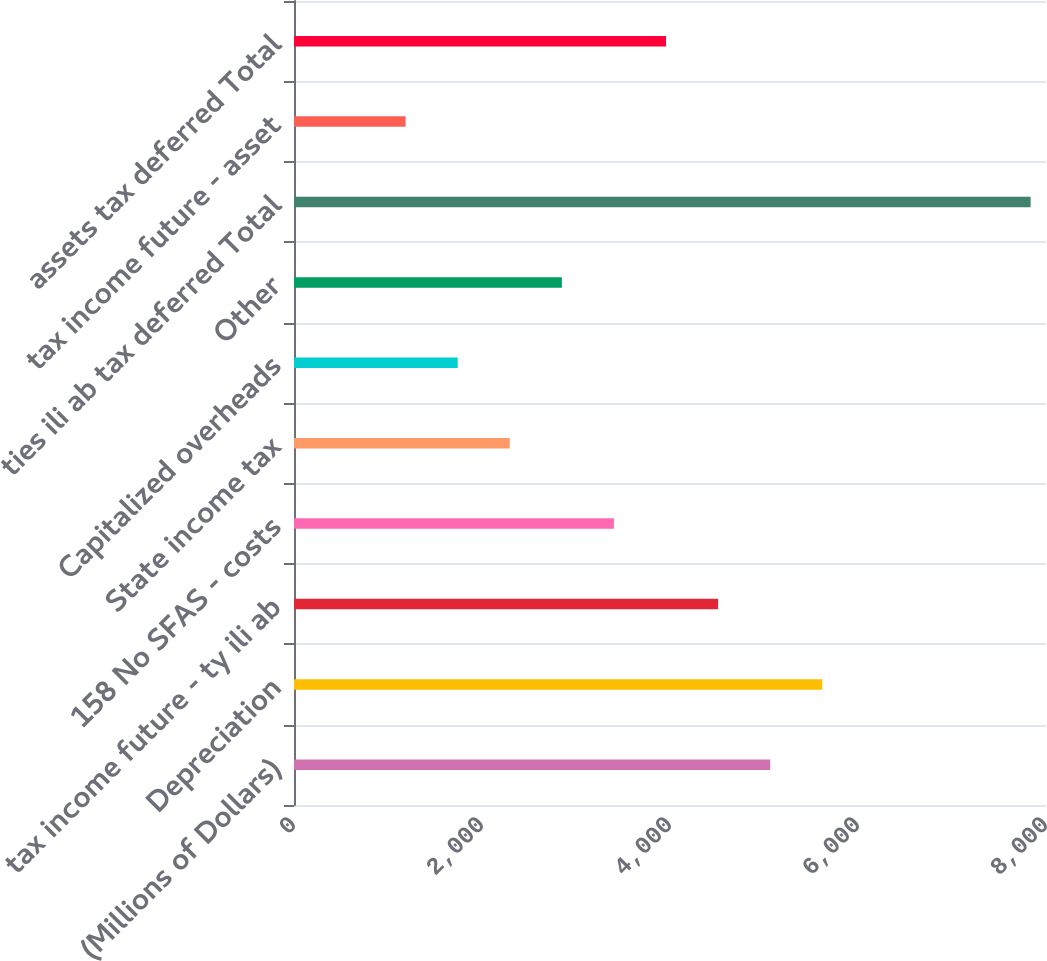Convert chart to OTSL. <chart><loc_0><loc_0><loc_500><loc_500><bar_chart><fcel>(Millions of Dollars)<fcel>Depreciation<fcel>tax income future - ty ili ab<fcel>158 No SFAS - costs<fcel>State income tax<fcel>Capitalized overheads<fcel>Other<fcel>ties ili ab tax deferred Total<fcel>tax income future - asset<fcel>assets tax deferred Total<nl><fcel>5065.9<fcel>5620<fcel>4511.8<fcel>3403.6<fcel>2295.4<fcel>1741.3<fcel>2849.5<fcel>7836.4<fcel>1187.2<fcel>3957.7<nl></chart> 